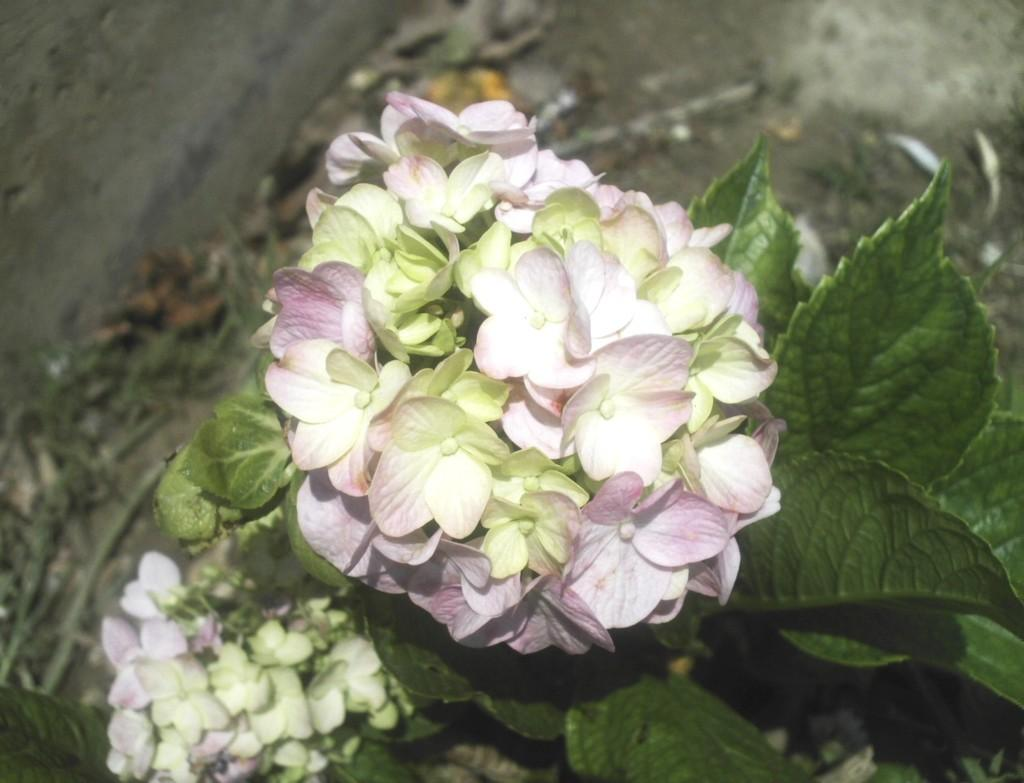What is the main subject in the center of the image? There are flowers and leaves in the center of the image. Can you describe the appearance of the flowers and leaves? Unfortunately, the appearance of the flowers and leaves cannot be described in detail based on the provided facts. What can be seen in the background of the image? There is ground visible in the background of the image. What type of riddle can be heard being solved by the flowers in the image? There is no indication in the image that the flowers are solving a riddle or engaging in any activity. How many bells are hanging from the leaves in the image? There are no bells present in the image; it features flowers and leaves. 